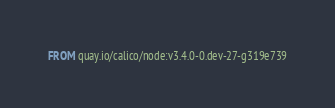Convert code to text. <code><loc_0><loc_0><loc_500><loc_500><_Dockerfile_>FROM quay.io/calico/node:v3.4.0-0.dev-27-g319e739
</code> 